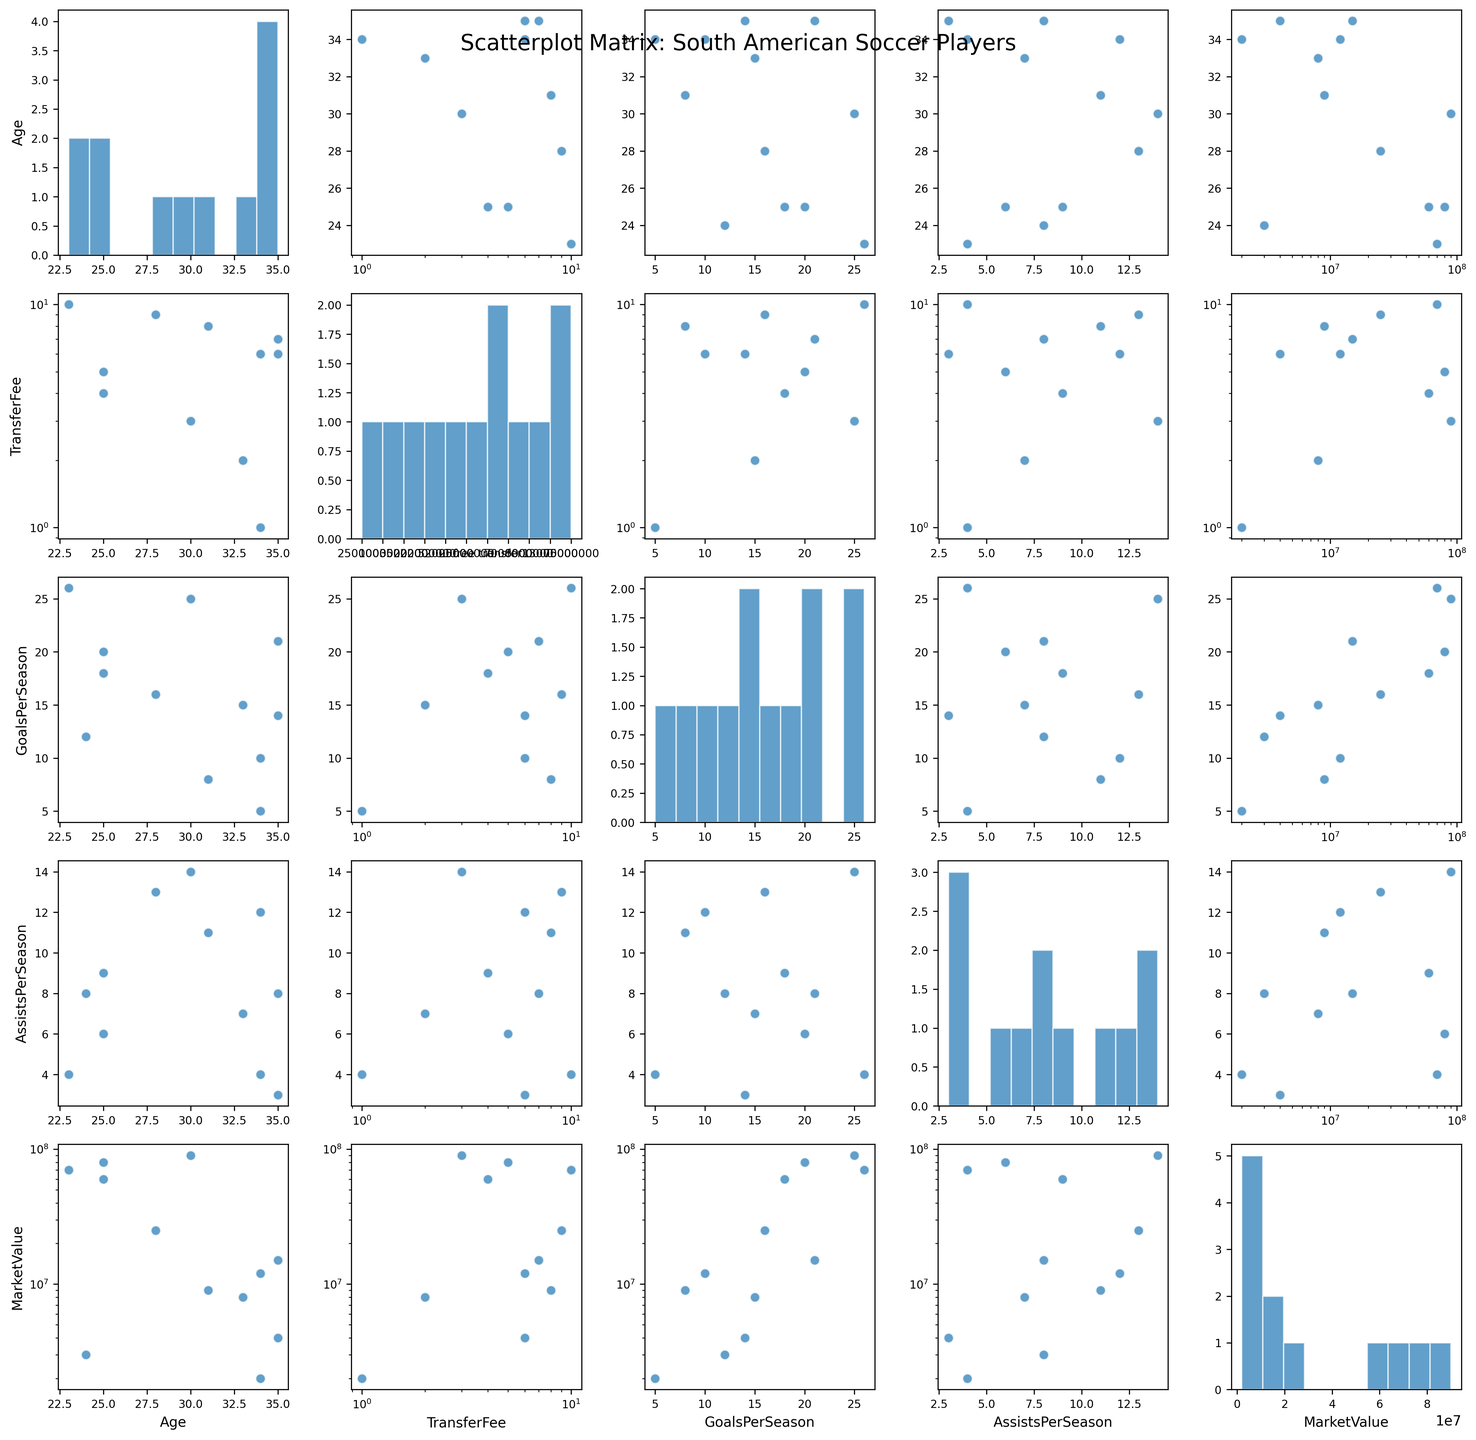What's the title of the figure? The main title is usually placed at the top of the plot. From the generated plot description, we know the title is provided there.
Answer: Scatterplot Matrix: South American Soccer Players Which variable has a logarithmic scale on both axes in the scatterplot? From the code, `TransferFee` and `MarketValue` both use a logarithmic scale if they appear on the x or y axes. So, we look for intersections of these two variables.
Answer: TransferFee and MarketValue How does Age relate to MarketValue based on the scatterplot matrix? To answer this, we look at the scatterplot in the matrix where Age is plotted against MarketValue to identify any patterns. We notice that as age increases, MarketValue generally decreases.
Answer: Older players tend to have a lower market value What's the range of GoalsPerSeason among the players? To determine the range, we need to look at the histogram of GoalsPerSeason. The minimum value appears close to 5, and the maximum value is around 26.
Answer: 5 to 26 Is there a strong correlation between GoalsPerSeason and AssistsPerSeason? We examine the scatterplot of GoalsPerSeason vs. AssistsPerSeason. Points that form a clear linear pattern indicate a strong correlation, but here it's less distinct, suggesting a weak or no strong correlation.
Answer: No strong correlation Which player has the highest transfer fee and how is he depicted on the plot? By looking at the respective plot, the highest transfer fee is associated with Neymar. We identify him in the scatterplots involving TransferFee.
Answer: Neymar Do players with higher market values tend to be younger? We check the scatterplot of Age vs. MarketValue to see if younger players generally have higher market values. There's a visible trend that younger players tend to have a higher market value.
Answer: Yes Which statistics seem to have a similar distribution pattern when you compare their histograms? We look at the histograms on the diagonal and find that GoalsPerSeason and AssistsPerSeason appear to have distributions of similar shape and spread.
Answer: GoalsPerSeason and AssistsPerSeason How many players have been transferred for a fee versus a free transfer? From the TransferFee histograms and scatterplots, we note the number of players with transfer fees and free transfers. Two players, Edinson Cavani and Ángel Di María, have "free transfer" status.
Answer: 10 players with transfer fees, 2 players with free transfer Does Market Value appear to correlate more strongly with GoalsPerSeason or AssistsPerSeason? By examining the scatterplots of MarketValue with GoalsPerSeason and AssistsPerSeason, we can compare the density and linearity of data points. MarketValue shows a stronger alignment with GoalsPerSeason.
Answer: GoalsPerSeason 